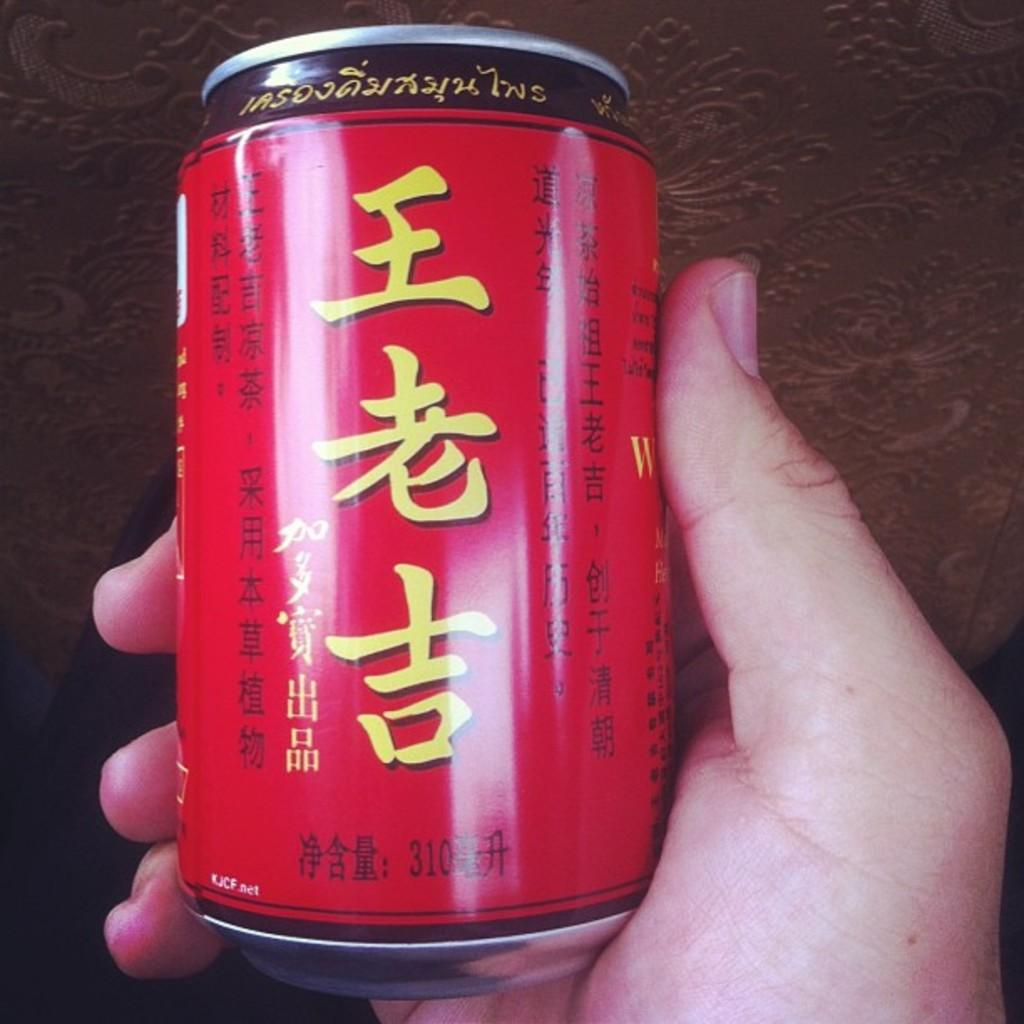<image>
Summarize the visual content of the image. A red tin on drink with the letters KJCF.net written on the bottom. 